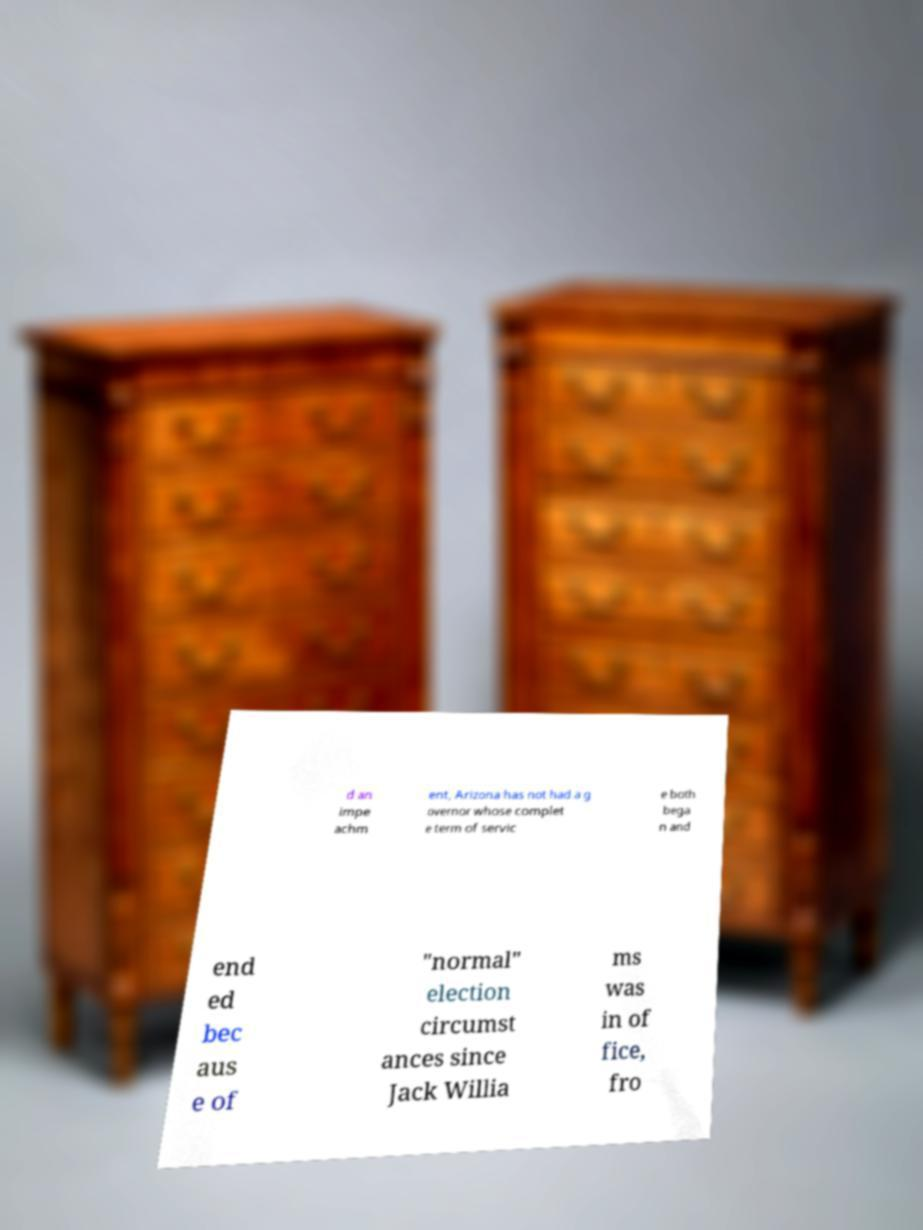Please identify and transcribe the text found in this image. d an impe achm ent, Arizona has not had a g overnor whose complet e term of servic e both bega n and end ed bec aus e of "normal" election circumst ances since Jack Willia ms was in of fice, fro 